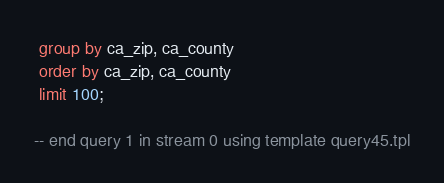<code> <loc_0><loc_0><loc_500><loc_500><_SQL_> group by ca_zip, ca_county
 order by ca_zip, ca_county
 limit 100;

-- end query 1 in stream 0 using template query45.tpl
</code> 